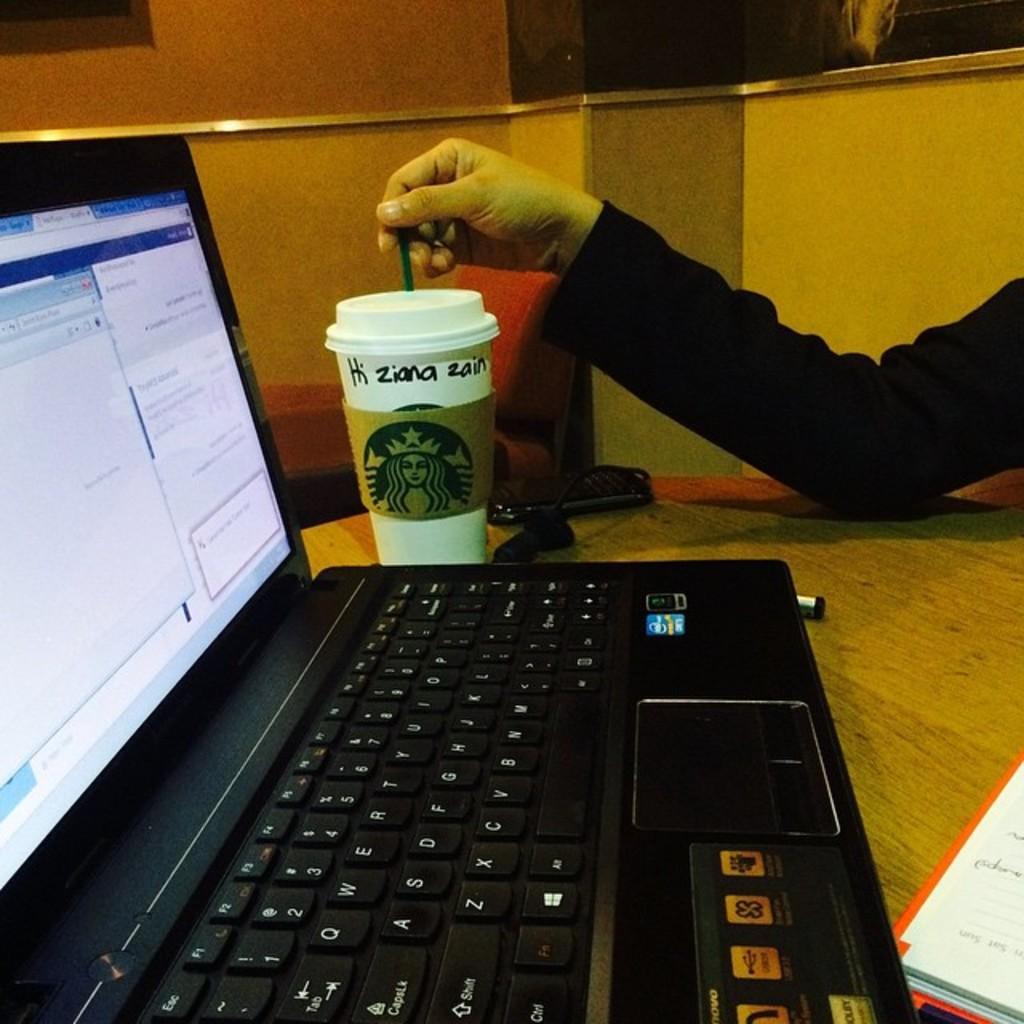Please provide a concise description of this image. In this picture there is a laptop on the table and a star buck coffee cup on which HI ZIANA ZAIN is written. 